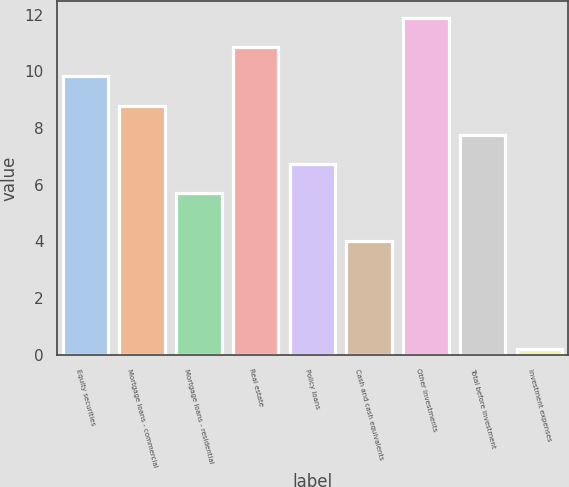<chart> <loc_0><loc_0><loc_500><loc_500><bar_chart><fcel>Equity securities<fcel>Mortgage loans - commercial<fcel>Mortgage loans - residential<fcel>Real estate<fcel>Policy loans<fcel>Cash and cash equivalents<fcel>Other investments<fcel>Total before investment<fcel>Investment expenses<nl><fcel>9.82<fcel>8.79<fcel>5.7<fcel>10.85<fcel>6.73<fcel>4<fcel>11.88<fcel>7.76<fcel>0.2<nl></chart> 